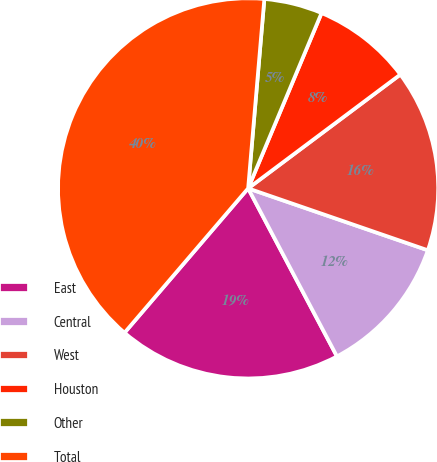Convert chart to OTSL. <chart><loc_0><loc_0><loc_500><loc_500><pie_chart><fcel>East<fcel>Central<fcel>West<fcel>Houston<fcel>Other<fcel>Total<nl><fcel>19.01%<fcel>11.98%<fcel>15.5%<fcel>8.47%<fcel>4.95%<fcel>40.09%<nl></chart> 